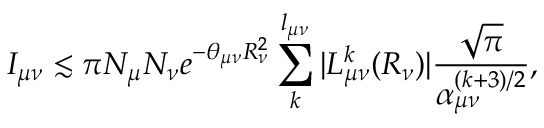<formula> <loc_0><loc_0><loc_500><loc_500>I _ { \mu \nu } \lesssim \pi N _ { \mu } N _ { \nu } e ^ { - \theta _ { \mu \nu } R _ { \nu } ^ { 2 } } \sum _ { k } ^ { l _ { \mu \nu } } | L _ { \mu \nu } ^ { k } ( R _ { \nu } ) | \frac { \sqrt { \pi } } { \alpha _ { \mu \nu } ^ { ( k + 3 ) / 2 } } ,</formula> 